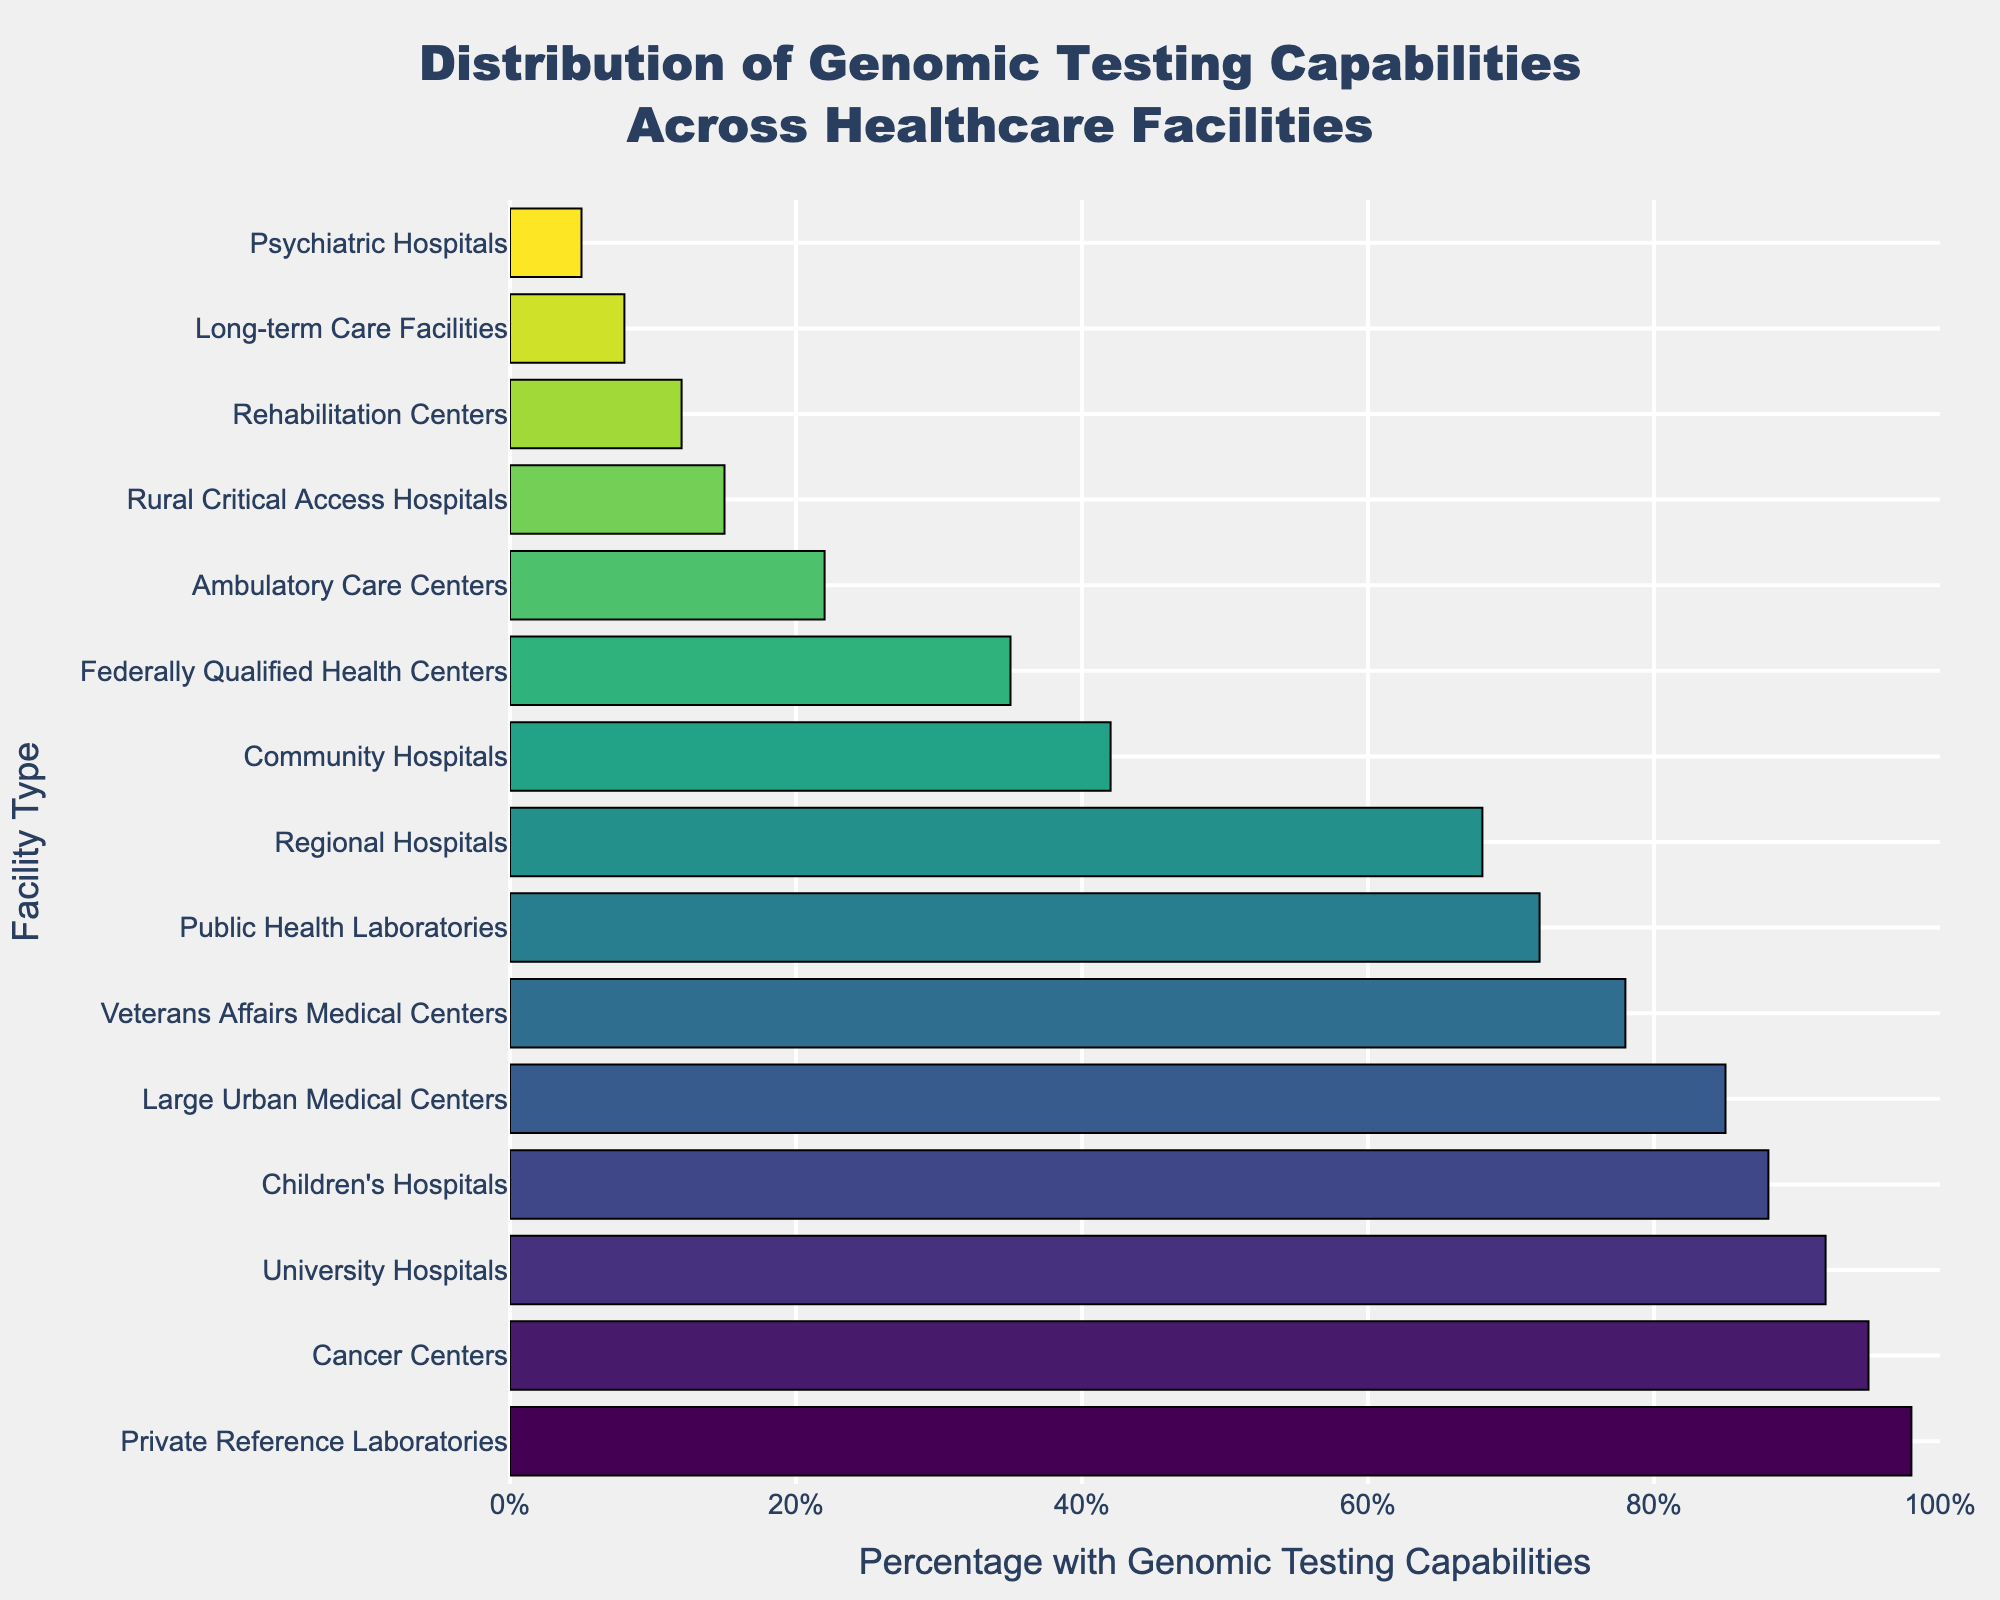Which facility type has the highest percentage of genomic testing capabilities? Look at the bar chart and find the bar that has the longest length, indicating the highest percentage. This bar corresponds to the Private Reference Laboratories with 98%.
Answer: Private Reference Laboratories Which facility type has the lowest percentage of genomic testing capabilities? Identify the bar with the shortest length, which represents the lowest percentage. This is the Psychiatric Hospitals with 5%.
Answer: Psychiatric Hospitals What is the difference in percentage of genomic testing capabilities between Cancer Centers and Community Hospitals? Locate the percentages for both Cancer Centers (95%) and Community Hospitals (42%). Subtract the percentage of Community Hospitals from that of Cancer Centers: 95% - 42% = 53%.
Answer: 53% If you combine University Hospitals and Veterans Affairs Medical Centers, what is their average percentage of genomic testing capabilities? Identify the percentages for University Hospitals (92%) and Veterans Affairs Medical Centers (78%). Add them together and divide by 2: (92% + 78%) / 2 = 85%.
Answer: 85% What is the percentage range of genomic testing capabilities among the listed facilities? Identify the highest percentage (98% for Private Reference Laboratories) and the lowest percentage (5% for Psychiatric Hospitals) and find the range by subtracting the lowest from the highest: 98% - 5% = 93%.
Answer: 93% Which three facility types have percentages closest to 70%? Look for the bars whose lengths represent percentages near 70%. The closest percentages to 70% are Regional Hospitals (68%), Public Health Laboratories (72%), and Veterans Affairs Medical Centers (78%).
Answer: Regional Hospitals, Public Health Laboratories, Veterans Affairs Medical Centers How much higher is the percentage of genomic testing capabilities in Cancer Centers compared to Public Health Laboratories? Identify the percentages for Cancer Centers (95%) and Public Health Laboratories (72%). Subtract the percentage of Public Health Laboratories from that of Cancer Centers: 95% - 72% = 23%.
Answer: 23% What is the median percentage of genomic testing capabilities across all facility types? First, arrange the percentages in ascending order: 5, 8, 12, 15, 22, 35, 42, 68, 72, 78, 85, 88, 92, 95, 98. Since there are 15 data points, the median is the 8th value: 68%.
Answer: 68% Which facility types fall within the bottom 25% of genomic testing capabilities? With 15 data points, the bottom 25% would be approximately the lowest 4 values. The facility types with the lowest percentages are Psychiatric Hospitals (5%), Long-term Care Facilities (8%), Rehabilitation Centers (12%), and Rural Critical Access Hospitals (15%).
Answer: Psychiatric Hospitals, Long-term Care Facilities, Rehabilitation Centers, Rural Critical Access Hospitals What is the sum of the percentages for Ambulatory Care Centers, Long-term Care Facilities, Psychiatric Hospitals, and Rehabilitation Centers? Identify each percentage: Ambulatory Care Centers (22%), Long-term Care Facilities (8%), Psychiatric Hospitals (5%), and Rehabilitation Centers (12%). Add them together: 22% + 8% + 5% + 12% = 47%.
Answer: 47% 